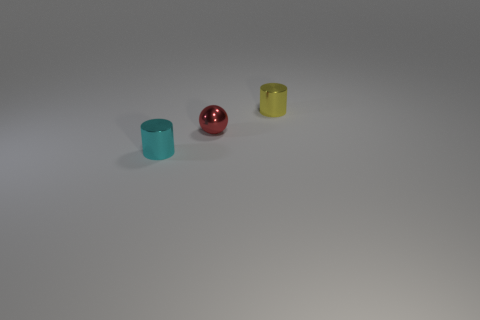Add 3 cyan objects. How many objects exist? 6 Subtract all cylinders. How many objects are left? 1 Subtract 1 balls. How many balls are left? 0 Subtract all yellow balls. Subtract all cyan cubes. How many balls are left? 1 Subtract all yellow cubes. How many brown cylinders are left? 0 Subtract all yellow shiny spheres. Subtract all small cylinders. How many objects are left? 1 Add 1 yellow shiny cylinders. How many yellow shiny cylinders are left? 2 Add 1 gray objects. How many gray objects exist? 1 Subtract 0 green balls. How many objects are left? 3 